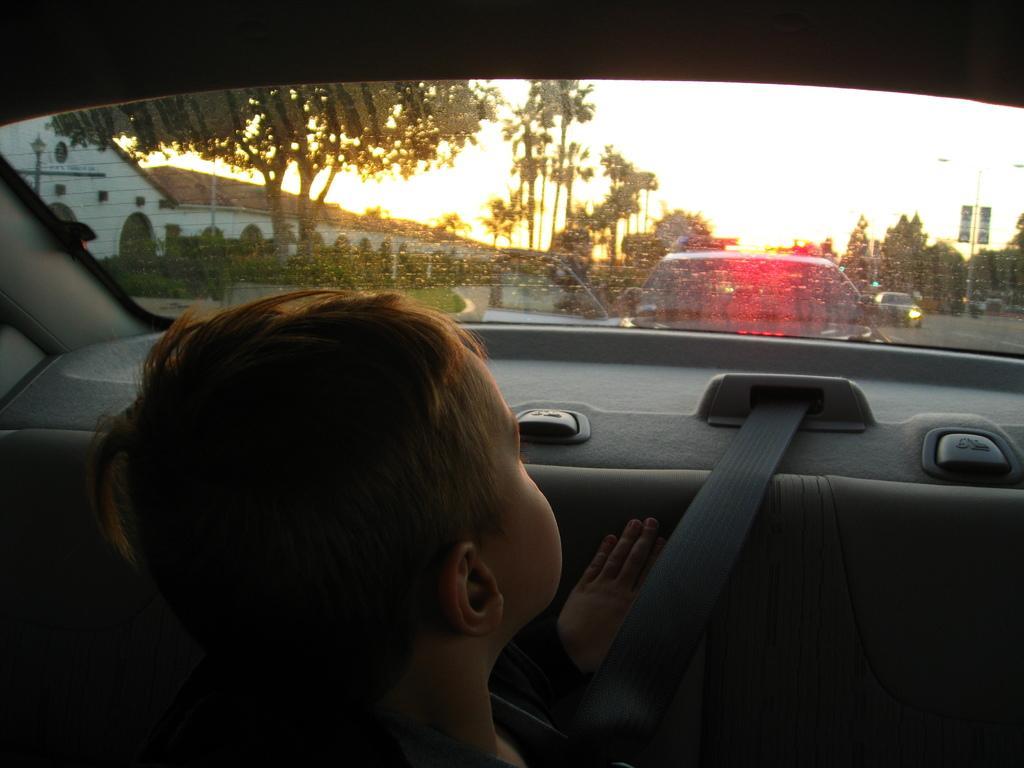Please provide a concise description of this image. In the image there is boy sat inside a car and outside the car its road and some cars going on it,on the right side there are trees and on top is sky and sun set 